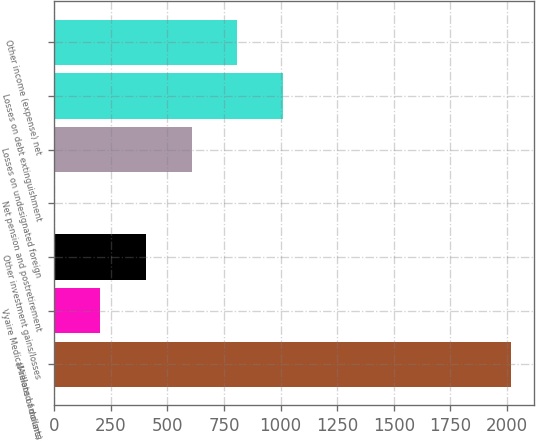Convert chart to OTSL. <chart><loc_0><loc_0><loc_500><loc_500><bar_chart><fcel>(Millions of dollars)<fcel>Vyaire Medical-related amounts<fcel>Other investment gains/losses<fcel>Net pension and postretirement<fcel>Losses on undesignated foreign<fcel>Losses on debt extinguishment<fcel>Other income (expense) net<nl><fcel>2019<fcel>203.7<fcel>405.4<fcel>2<fcel>607.1<fcel>1010.5<fcel>808.8<nl></chart> 